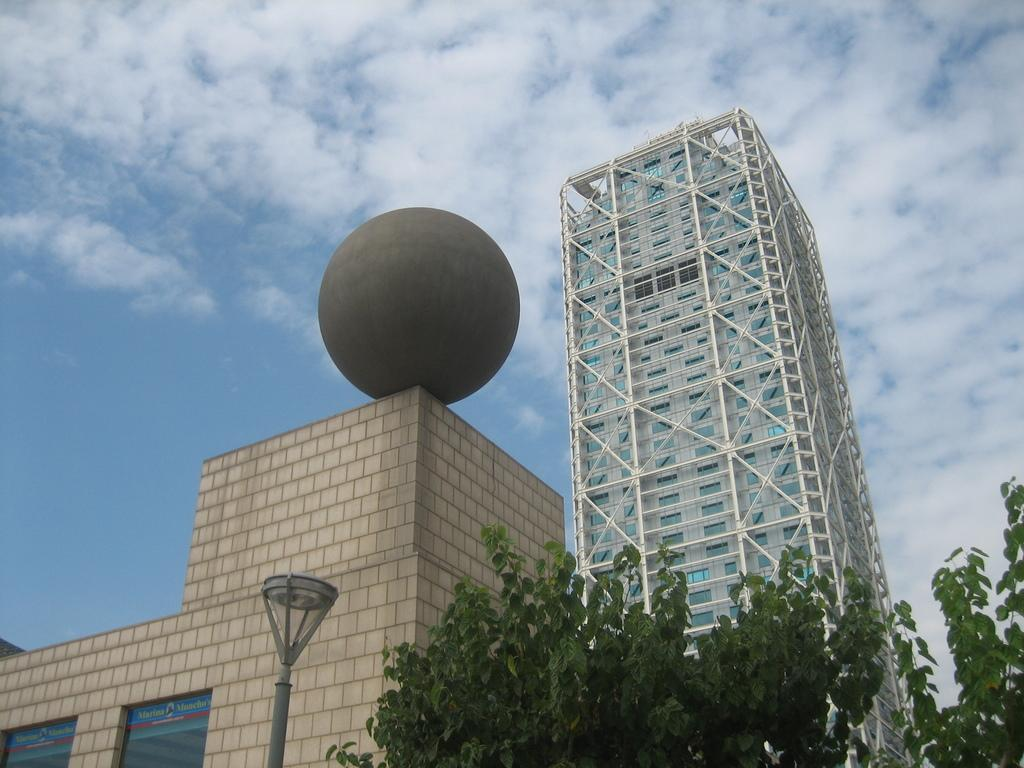What type of structures can be seen in the image? There are buildings in the image. What is located at the bottom of the image? There is a pole and trees at the bottom of the image. What can be seen in the background of the image? The sky is visible in the background of the image. Can you tell me how many beggars are present in the image? There are no beggars present in the image. What type of order is being followed by the stranger in the image? There is no stranger present in the image. 